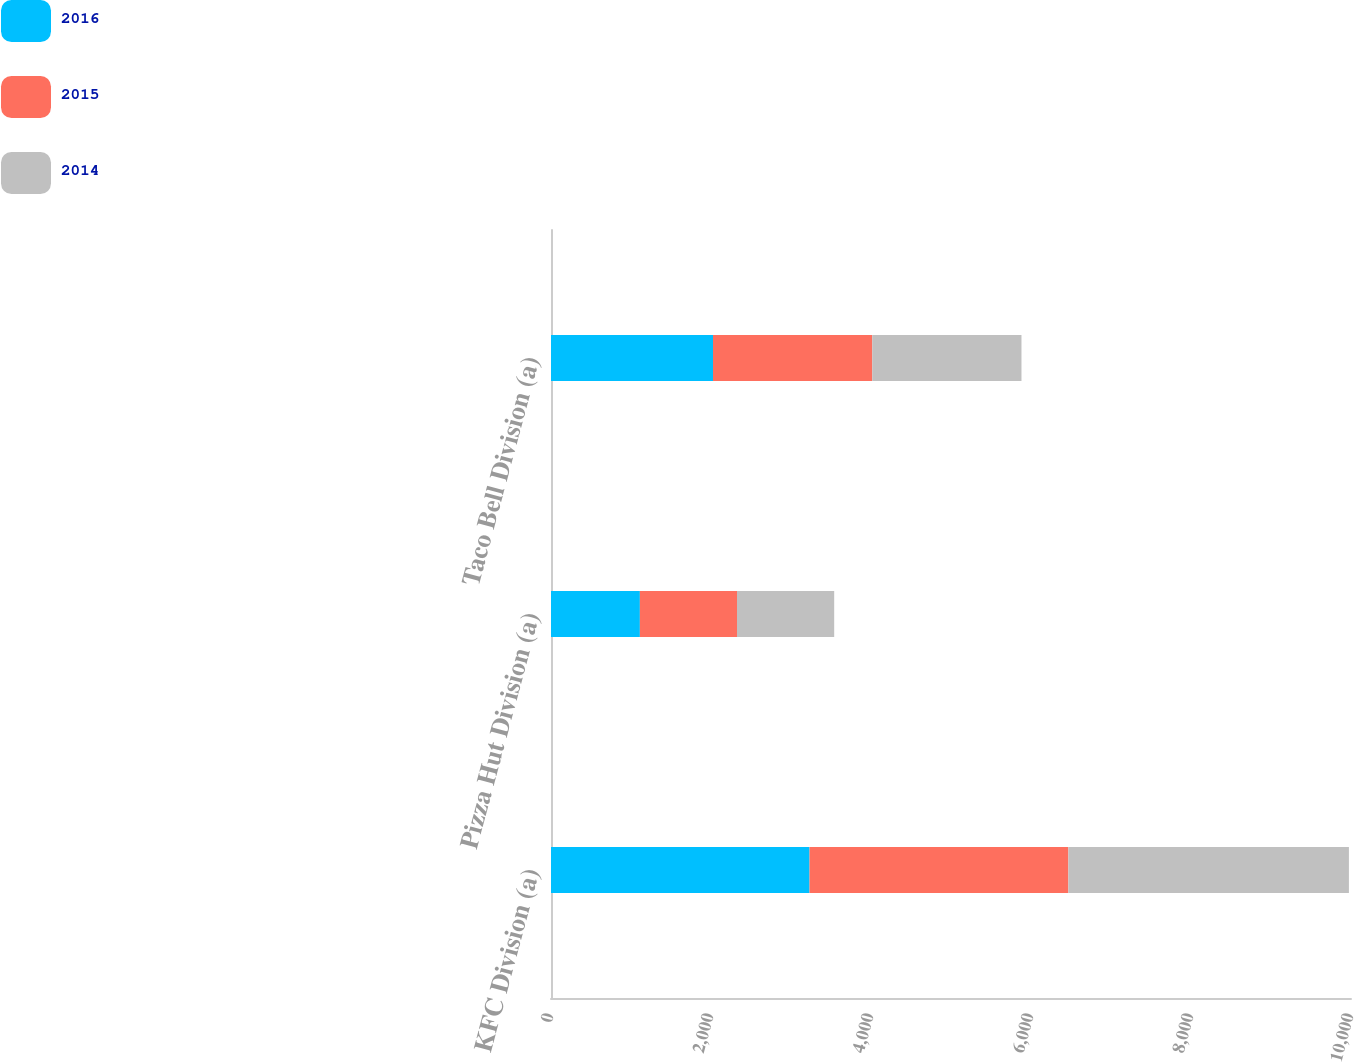Convert chart to OTSL. <chart><loc_0><loc_0><loc_500><loc_500><stacked_bar_chart><ecel><fcel>KFC Division (a)<fcel>Pizza Hut Division (a)<fcel>Taco Bell Division (a)<nl><fcel>2016<fcel>3232<fcel>1111<fcel>2025<nl><fcel>2015<fcel>3235<fcel>1214<fcel>1991<nl><fcel>2014<fcel>3507<fcel>1215<fcel>1865<nl></chart> 